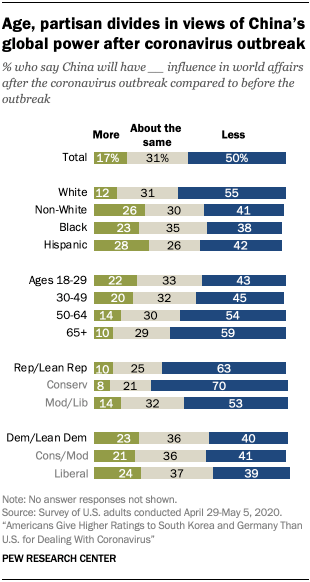Highlight a few significant elements in this photo. The bar graph uses three colors to represent various amounts of a certain substance. The question asks how many gray bars that have the value of 36? The question is phrased as a wh-question, with the wh-word being "that." The answer to this question is 2. 